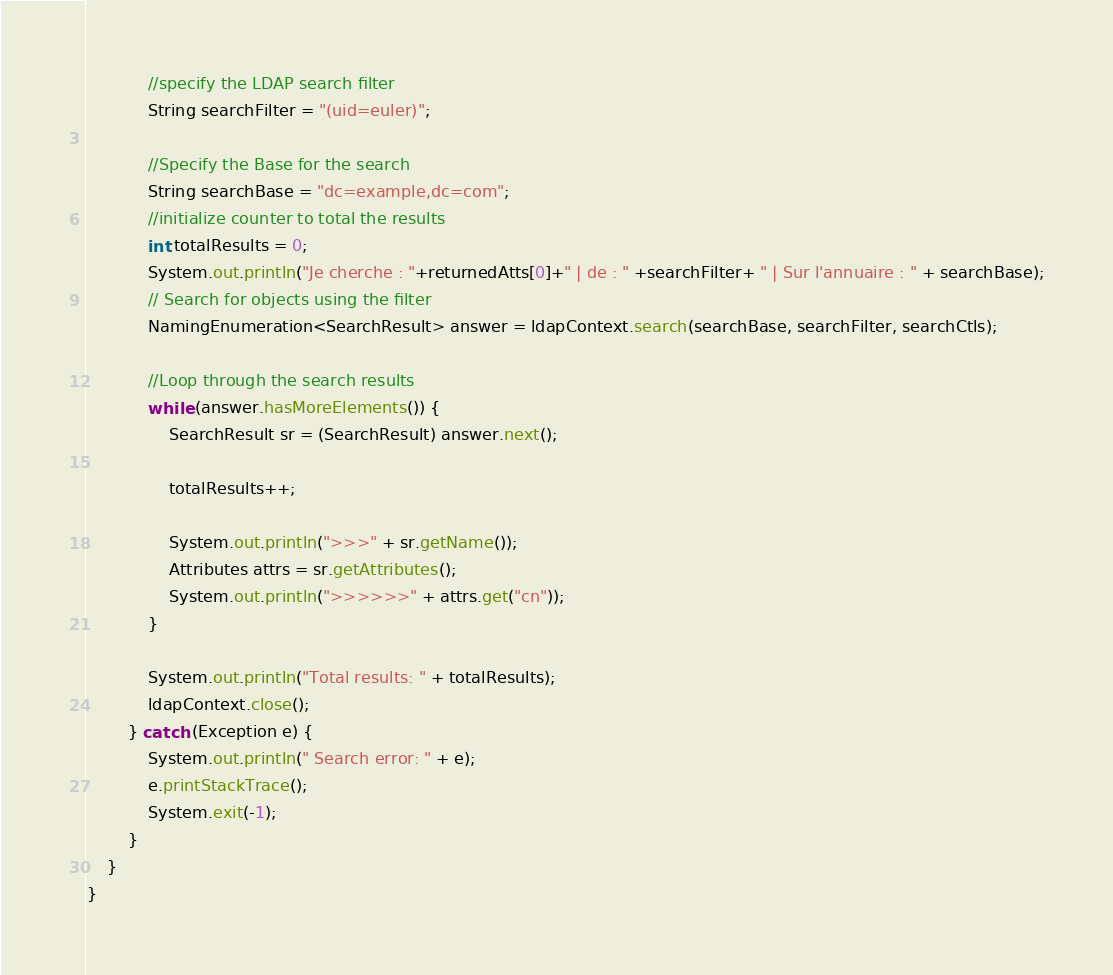<code> <loc_0><loc_0><loc_500><loc_500><_Java_>
            //specify the LDAP search filter
            String searchFilter = "(uid=euler)";

            //Specify the Base for the search
            String searchBase = "dc=example,dc=com";
            //initialize counter to total the results
            int totalResults = 0;
            System.out.println("Je cherche : "+returnedAtts[0]+" | de : " +searchFilter+ " | Sur l'annuaire : " + searchBase);
            // Search for objects using the filter
            NamingEnumeration<SearchResult> answer = ldapContext.search(searchBase, searchFilter, searchCtls);

            //Loop through the search results
            while (answer.hasMoreElements()) {
                SearchResult sr = (SearchResult) answer.next();

                totalResults++;

                System.out.println(">>>" + sr.getName());
                Attributes attrs = sr.getAttributes();
                System.out.println(">>>>>>" + attrs.get("cn"));
            }

            System.out.println("Total results: " + totalResults);
            ldapContext.close();
        } catch (Exception e) {
            System.out.println(" Search error: " + e);
            e.printStackTrace();
            System.exit(-1);
        }
    }
}
</code> 